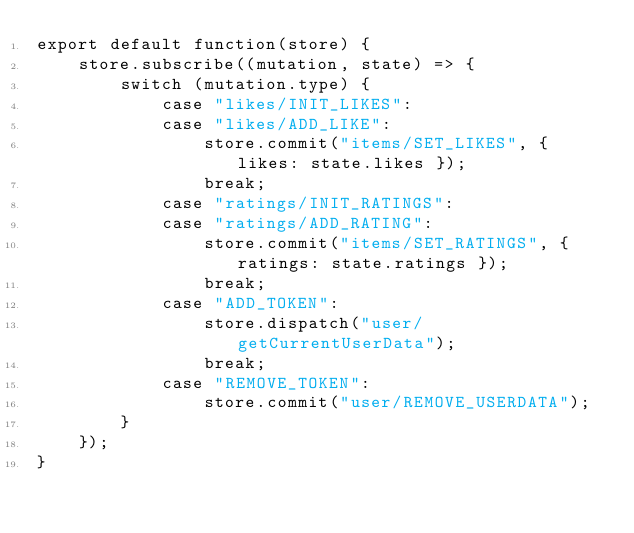Convert code to text. <code><loc_0><loc_0><loc_500><loc_500><_JavaScript_>export default function(store) {
    store.subscribe((mutation, state) => {
        switch (mutation.type) {
            case "likes/INIT_LIKES":
            case "likes/ADD_LIKE":
                store.commit("items/SET_LIKES", { likes: state.likes });
                break;
            case "ratings/INIT_RATINGS":
            case "ratings/ADD_RATING":
                store.commit("items/SET_RATINGS", { ratings: state.ratings });
                break;
            case "ADD_TOKEN":
                store.dispatch("user/getCurrentUserData");
                break;
            case "REMOVE_TOKEN":
                store.commit("user/REMOVE_USERDATA");
        }
    });
}
</code> 